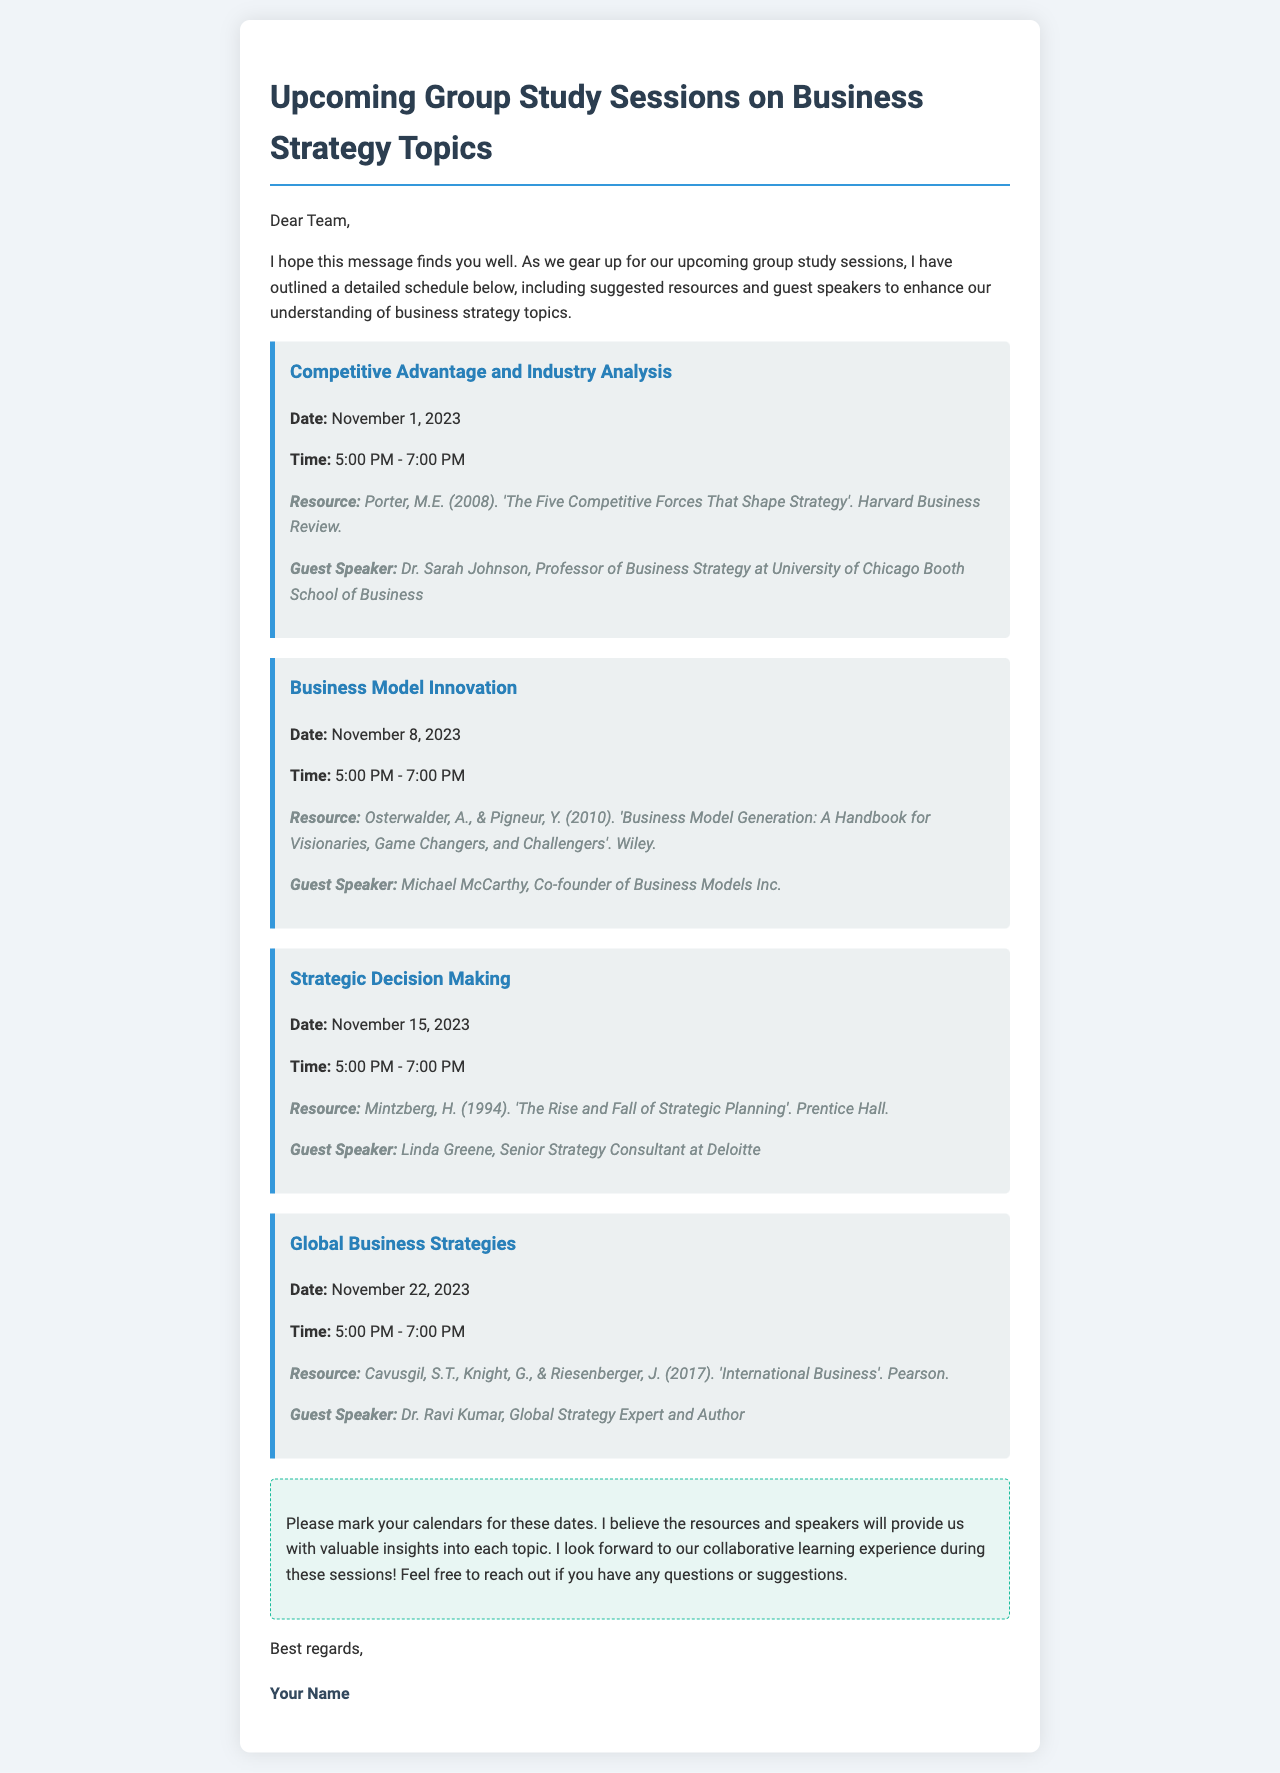What is the date of the first session? The first session is scheduled for November 1, 2023, as stated in the document.
Answer: November 1, 2023 Who is the guest speaker for the Business Model Innovation session? The document lists Michael McCarthy as the guest speaker for the Business Model Innovation session.
Answer: Michael McCarthy What time do the study sessions start? Each study session is scheduled to start at 5:00 PM according to the document.
Answer: 5:00 PM What resource is suggested for the session on Global Business Strategies? The document cites "Cavusgil, S.T., Knight, G., & Riesenberger, J." as the authors of the suggested resource for Global Business Strategies.
Answer: Cavusgil, S.T., Knight, G., & Riesenberger, J How many sessions are planned according to the document? The document outlines four sessions planned for the upcoming group study, as indicated by the individual session listings.
Answer: Four sessions What is the common time span for each study session? The sessions are consistently scheduled to last for two hours, from 5:00 PM to 7:00 PM.
Answer: Two hours Who is the guest speaker for the session on Strategic Decision Making? The guest speaker for Strategic Decision Making is identified in the document as Linda Greene.
Answer: Linda Greene 